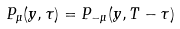Convert formula to latex. <formula><loc_0><loc_0><loc_500><loc_500>P _ { \mu } ( y , \tau ) = P _ { - \mu } ( y , T - \tau )</formula> 